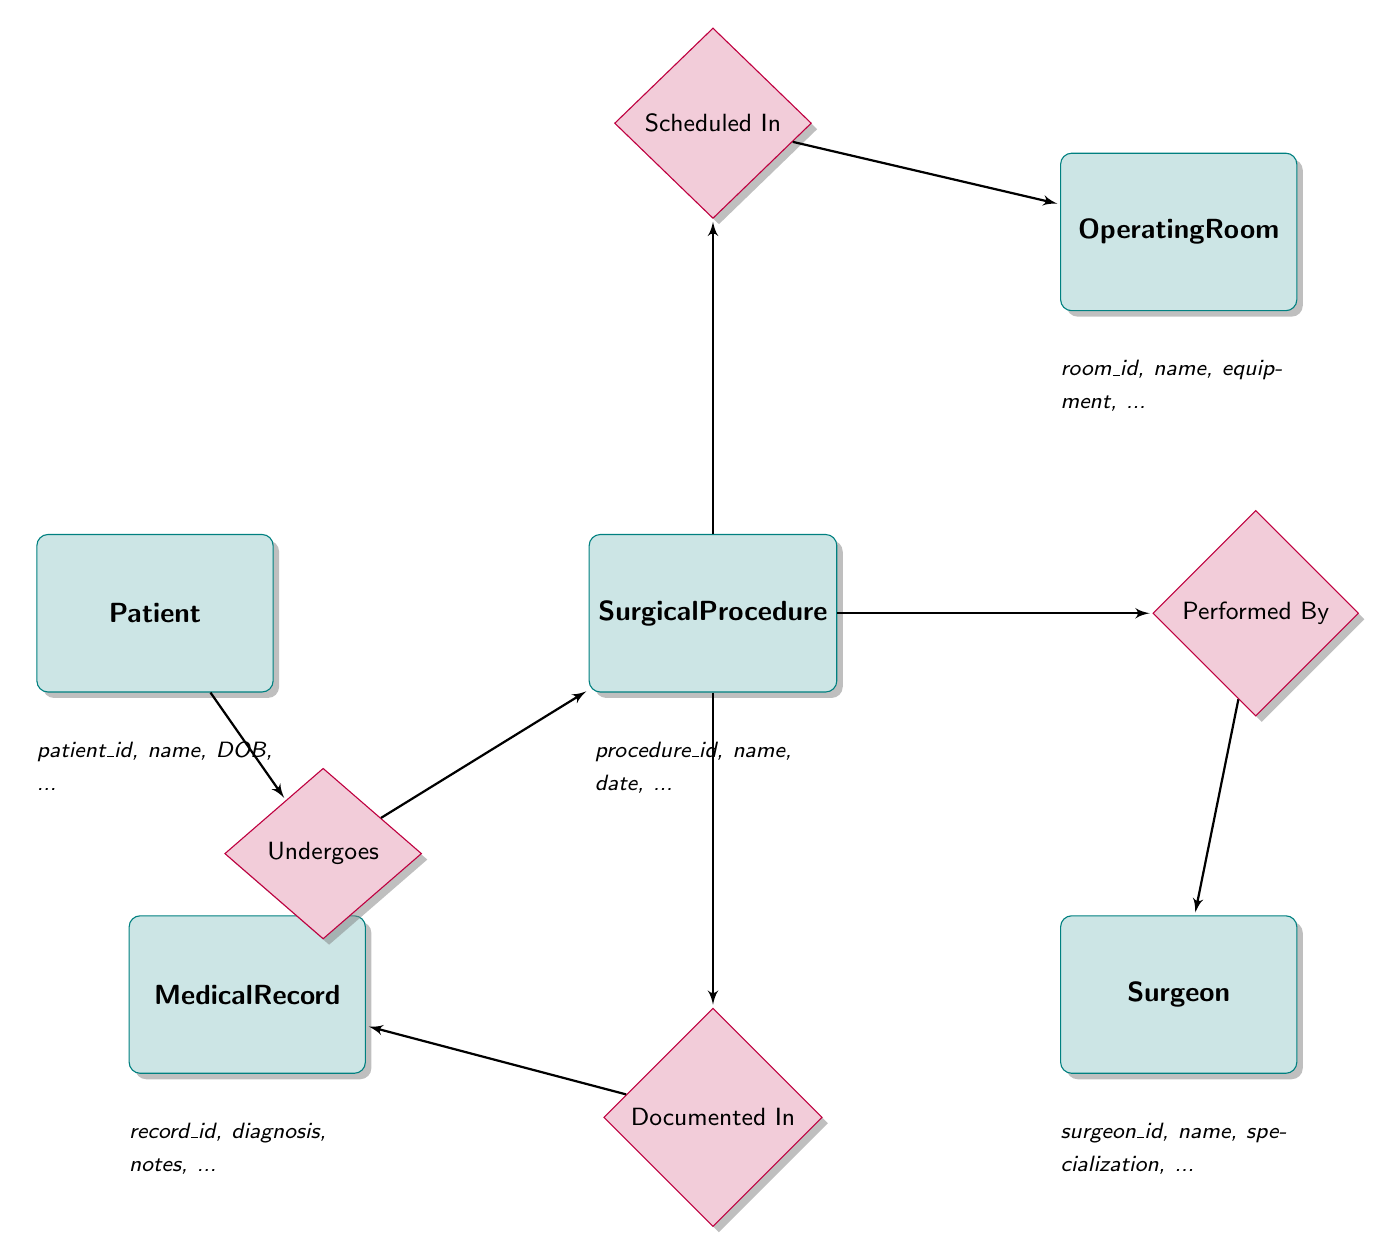What entities are present in the diagram? The diagram includes five entities: Patient, Surgical Procedure, Surgeon, Medical Record, and Operating Room. Each entity is represented by a rectangle with distinct attributes that define them.
Answer: Patient, Surgical Procedure, Surgeon, Medical Record, Operating Room What is the relationship between Patient and Surgical Procedure? The relationship is named "Undergoes." It indicates that the Patient undergoes a Surgical Procedure, emphasizing the connection between these two entities. The relationship is represented by a diamond shape, with lines connecting it to both entities.
Answer: Undergoes How many attributes does the Surgeon entity have? The Surgeon entity has five attributes: surgeon_id, first_name, last_name, specialization, and contact_info. These define the information related to the Surgeon in the system.
Answer: 5 Which entity is linked to the Operating Room? The Surgical Procedure entity is linked to the Operating Room through the relationship "Scheduled In." This shows that a specific surgical procedure is scheduled within a designated operating room.
Answer: Surgical Procedure What are the attributes of the Medical Record entity? The Medical Record entity has six attributes: record_id, patient_id, surgical_procedure_id, pre_op_diagnosis, post_op_notes, and medications_administered. These attributes capture critical information pertaining to the patient's medical record associated with surgical procedures.
Answer: record_id, patient_id, surgical_procedure_id, pre_op_diagnosis, post_op_notes, medications_administered What does the relationship "Documented In" signify? The relationship "Documented In" signifies that a Surgical Procedure is recorded in a Medical Record. This relationship is crucial for maintaining accurate records of medical procedures performed on patients.
Answer: Documented In Who performs a Surgical Procedure? The Surgeon performs a Surgical Procedure, as indicated by the relationship "Performed By." This highlights the role of the Surgeon in executing the surgical tasks outlined in the Surgical Procedure entity.
Answer: Surgeon Which entity would contain information about the medications administered during a surgical procedure? The Medical Record entity contains information about the medications administered during a surgical procedure, as one of its attributes specifically lists medications_administered.
Answer: Medical Record What is the purpose of the relationship "Scheduled In"? The relationship "Scheduled In" indicates that a Surgical Procedure is assigned to a specific Operating Room. This is essential for the logistics of surgical operations to ensure proper allocation of facilities.
Answer: Scheduled In 